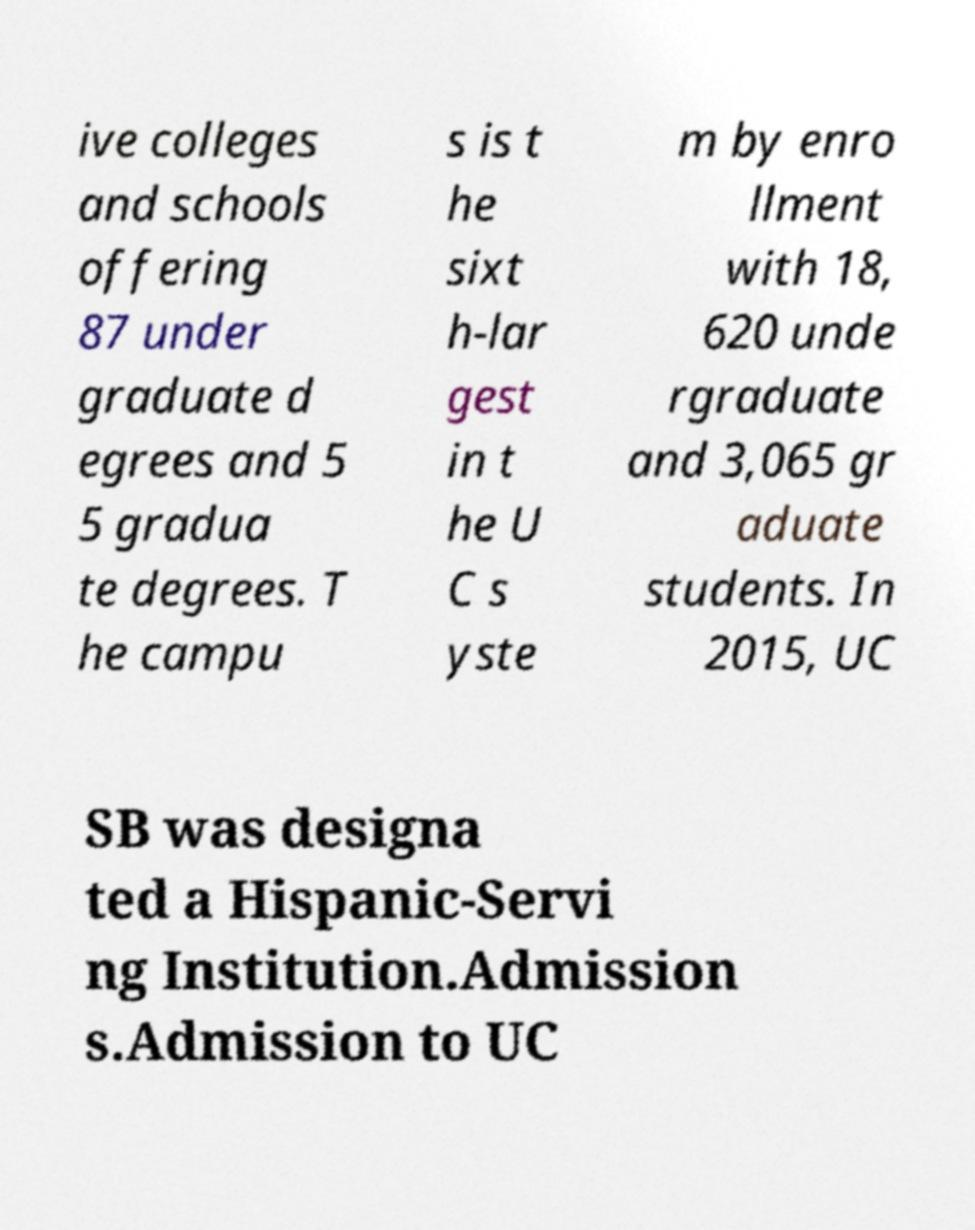Could you assist in decoding the text presented in this image and type it out clearly? ive colleges and schools offering 87 under graduate d egrees and 5 5 gradua te degrees. T he campu s is t he sixt h-lar gest in t he U C s yste m by enro llment with 18, 620 unde rgraduate and 3,065 gr aduate students. In 2015, UC SB was designa ted a Hispanic-Servi ng Institution.Admission s.Admission to UC 